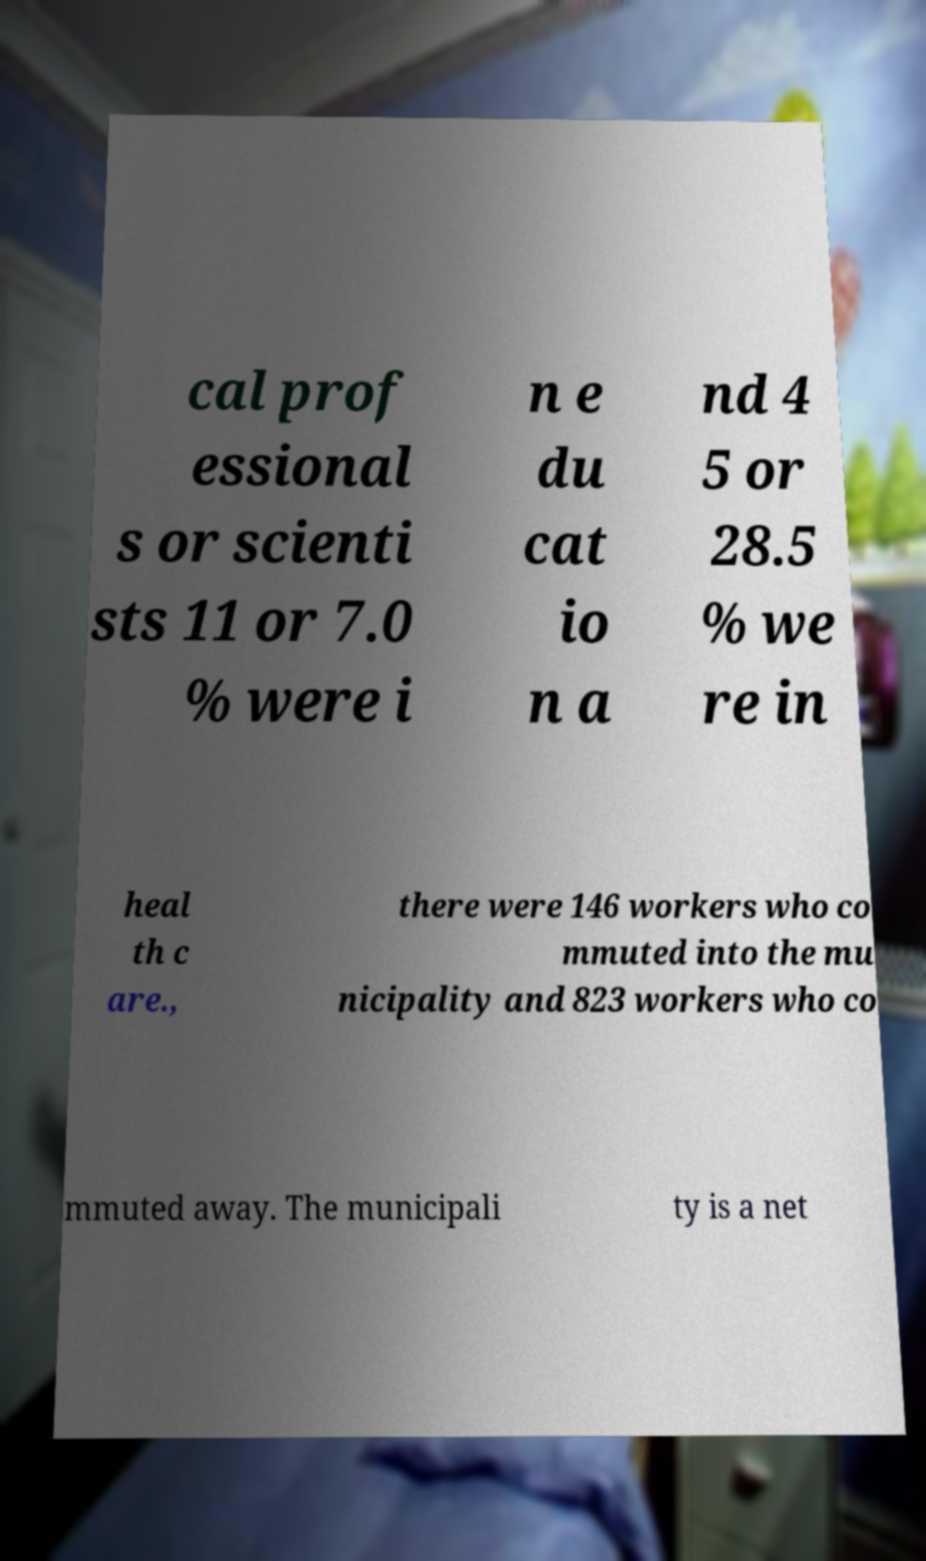I need the written content from this picture converted into text. Can you do that? cal prof essional s or scienti sts 11 or 7.0 % were i n e du cat io n a nd 4 5 or 28.5 % we re in heal th c are., there were 146 workers who co mmuted into the mu nicipality and 823 workers who co mmuted away. The municipali ty is a net 